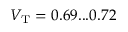<formula> <loc_0><loc_0><loc_500><loc_500>V _ { T } = 0 . 6 9 \dots 0 . 7 2</formula> 